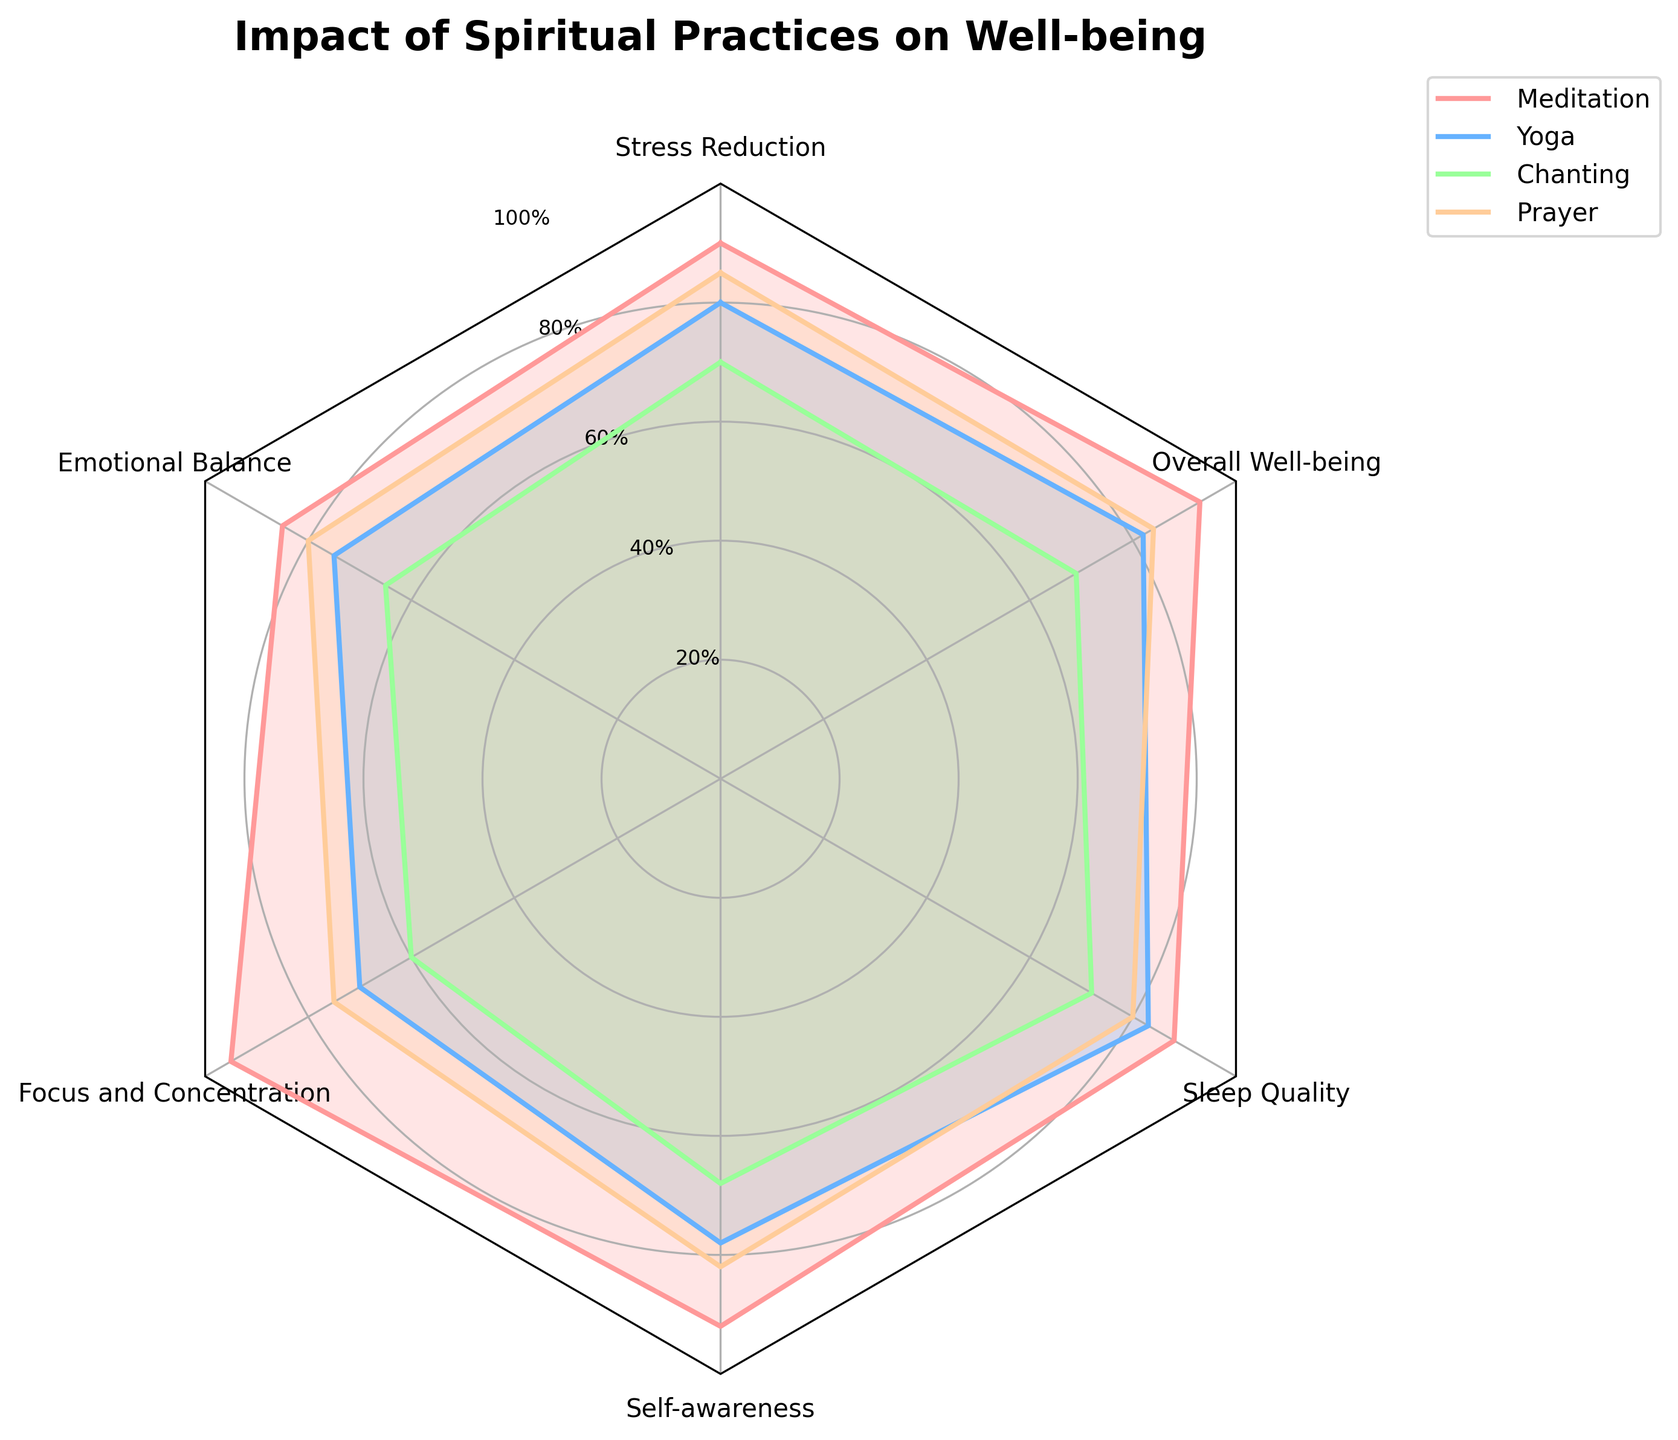What's the title of the radar chart? The title of the radar chart is prominently displayed at the top of the figure.
Answer: Impact of Spiritual Practices on Well-being Which spiritual practice has the highest score in "Focus and Concentration"? By looking at the plotted values on the radar chart, the highest score in "Focus and Concentration" is achieved by Meditation.
Answer: Meditation How does the effect of Yoga on "Sleep Quality" compare to that of Chanting? To determine this, check the values for "Sleep Quality" for both Yoga and Chanting on the radar chart. Yoga has a score of 83, and Chanting has a score of 72.
Answer: Yoga is higher Which dimension shows the smallest range of values among all spiritual practices? Calculate the range for each dimension by subtracting the smallest value from the largest value. The ranges are: Stress Reduction (70-90=20), Emotional Balance (65-85=20), Focus and Concentration (60-95=35), Self-awareness (68-92=24), Sleep Quality (72-88=16), and Overall Well-being (69-93=24).
Answer: Sleep Quality What is the average score of Prayer across all dimensions? Sum the scores for Prayer in all categories and divide by the total number of categories: (85 + 80 + 75 + 82 + 80 + 84)/6 = 486/6 = 81
Answer: 81 Which spiritual practice has the least impact on "Self-awareness"? Examine the values for "Self-awareness" in the radar chart, Chanting has the lowest score at 68.
Answer: Chanting Is the score for Yoga in "Overall Well-being" closer to that of Meditation or Prayer? Compare the "Overall Well-being" scores: Yoga (82), Meditation (93), and Prayer (84). The difference between Yoga and Meditation is 11, and between Yoga and Prayer is 2.
Answer: Prayer Between which two dimensions is Meditation's score the maximum difference? Identify the scores for Meditation in all dimensions and compute the pairwise differences. The maximum difference is between "Focus and Concentration" (95) and any of the others, and the largest difference is with "Chanting" at "Focus and Concentration" (60), which is a difference of 35 points.
Answer: Focus and Concentration and any other category In terms of "Stress Reduction", how much higher is Meditation's value than Chanting's? Subtract Chanting's score from Meditation's score for "Stress Reduction": 90 - 70 = 20.
Answer: 20 